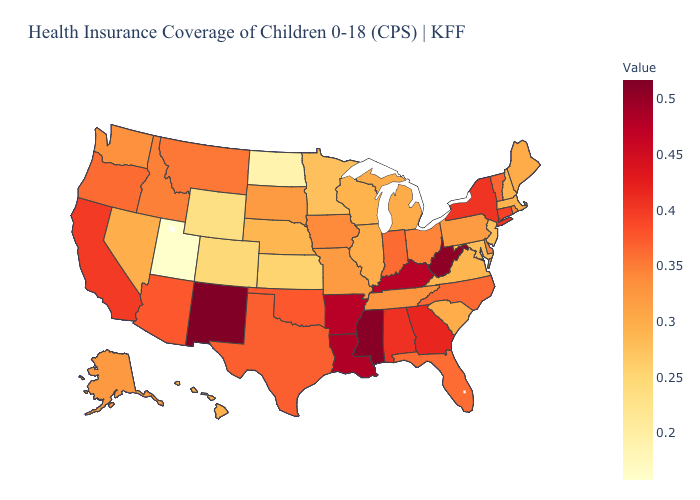Among the states that border New York , which have the highest value?
Quick response, please. Connecticut. Which states have the lowest value in the Northeast?
Be succinct. New Jersey. Which states have the lowest value in the Northeast?
Short answer required. New Jersey. Which states have the highest value in the USA?
Be succinct. New Mexico. 